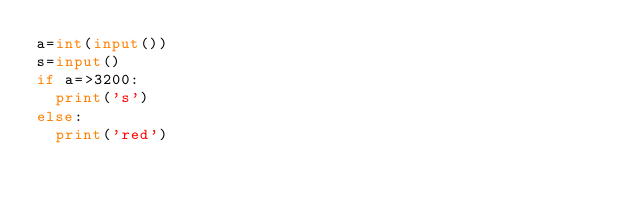<code> <loc_0><loc_0><loc_500><loc_500><_Python_>a=int(input())
s=input()
if a=>3200:
  print('s')
else:
  print('red')</code> 